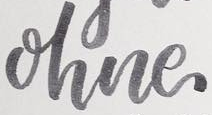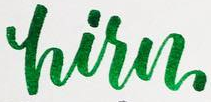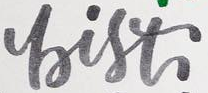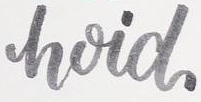What text appears in these images from left to right, separated by a semicolon? ohne; hisn; bist; hoid 